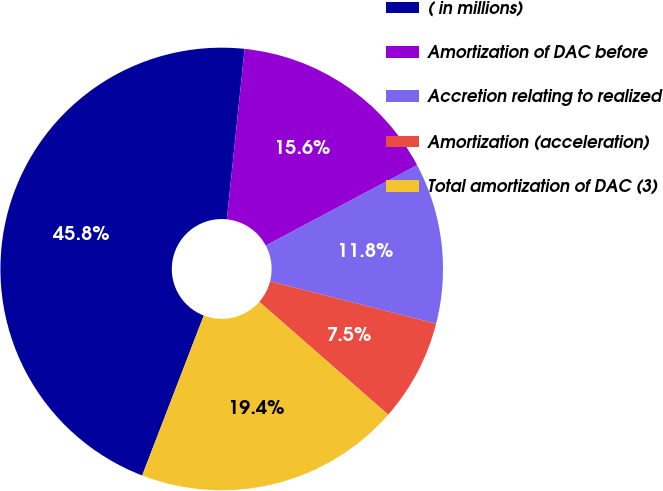<chart> <loc_0><loc_0><loc_500><loc_500><pie_chart><fcel>( in millions)<fcel>Amortization of DAC before<fcel>Accretion relating to realized<fcel>Amortization (acceleration)<fcel>Total amortization of DAC (3)<nl><fcel>45.8%<fcel>15.58%<fcel>11.75%<fcel>7.46%<fcel>19.41%<nl></chart> 